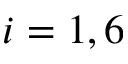Convert formula to latex. <formula><loc_0><loc_0><loc_500><loc_500>i = 1 , 6</formula> 